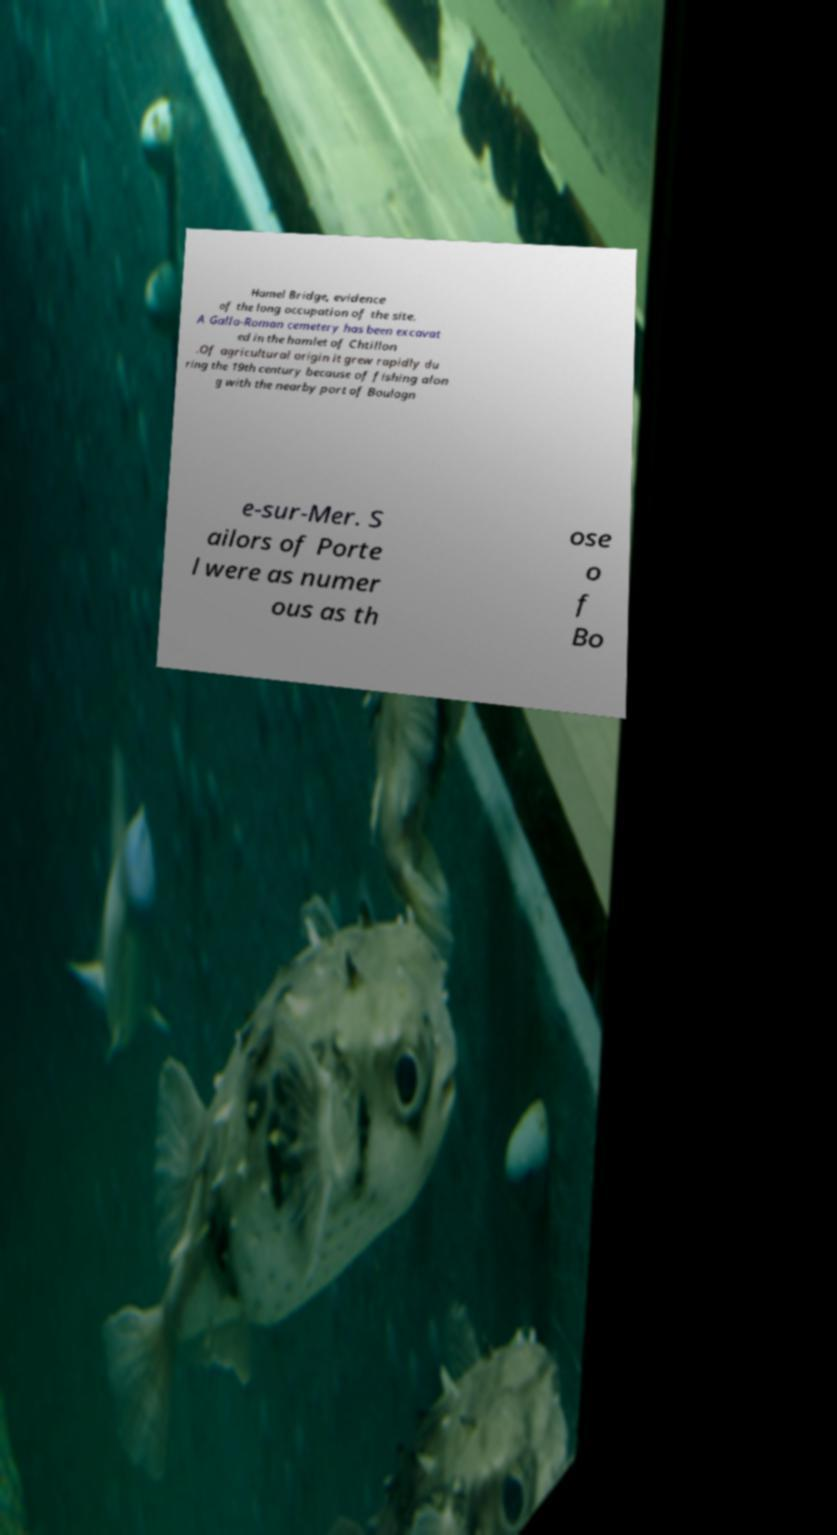What messages or text are displayed in this image? I need them in a readable, typed format. Hamel Bridge, evidence of the long occupation of the site. A Gallo-Roman cemetery has been excavat ed in the hamlet of Chtillon .Of agricultural origin it grew rapidly du ring the 19th century because of fishing alon g with the nearby port of Boulogn e-sur-Mer. S ailors of Porte l were as numer ous as th ose o f Bo 